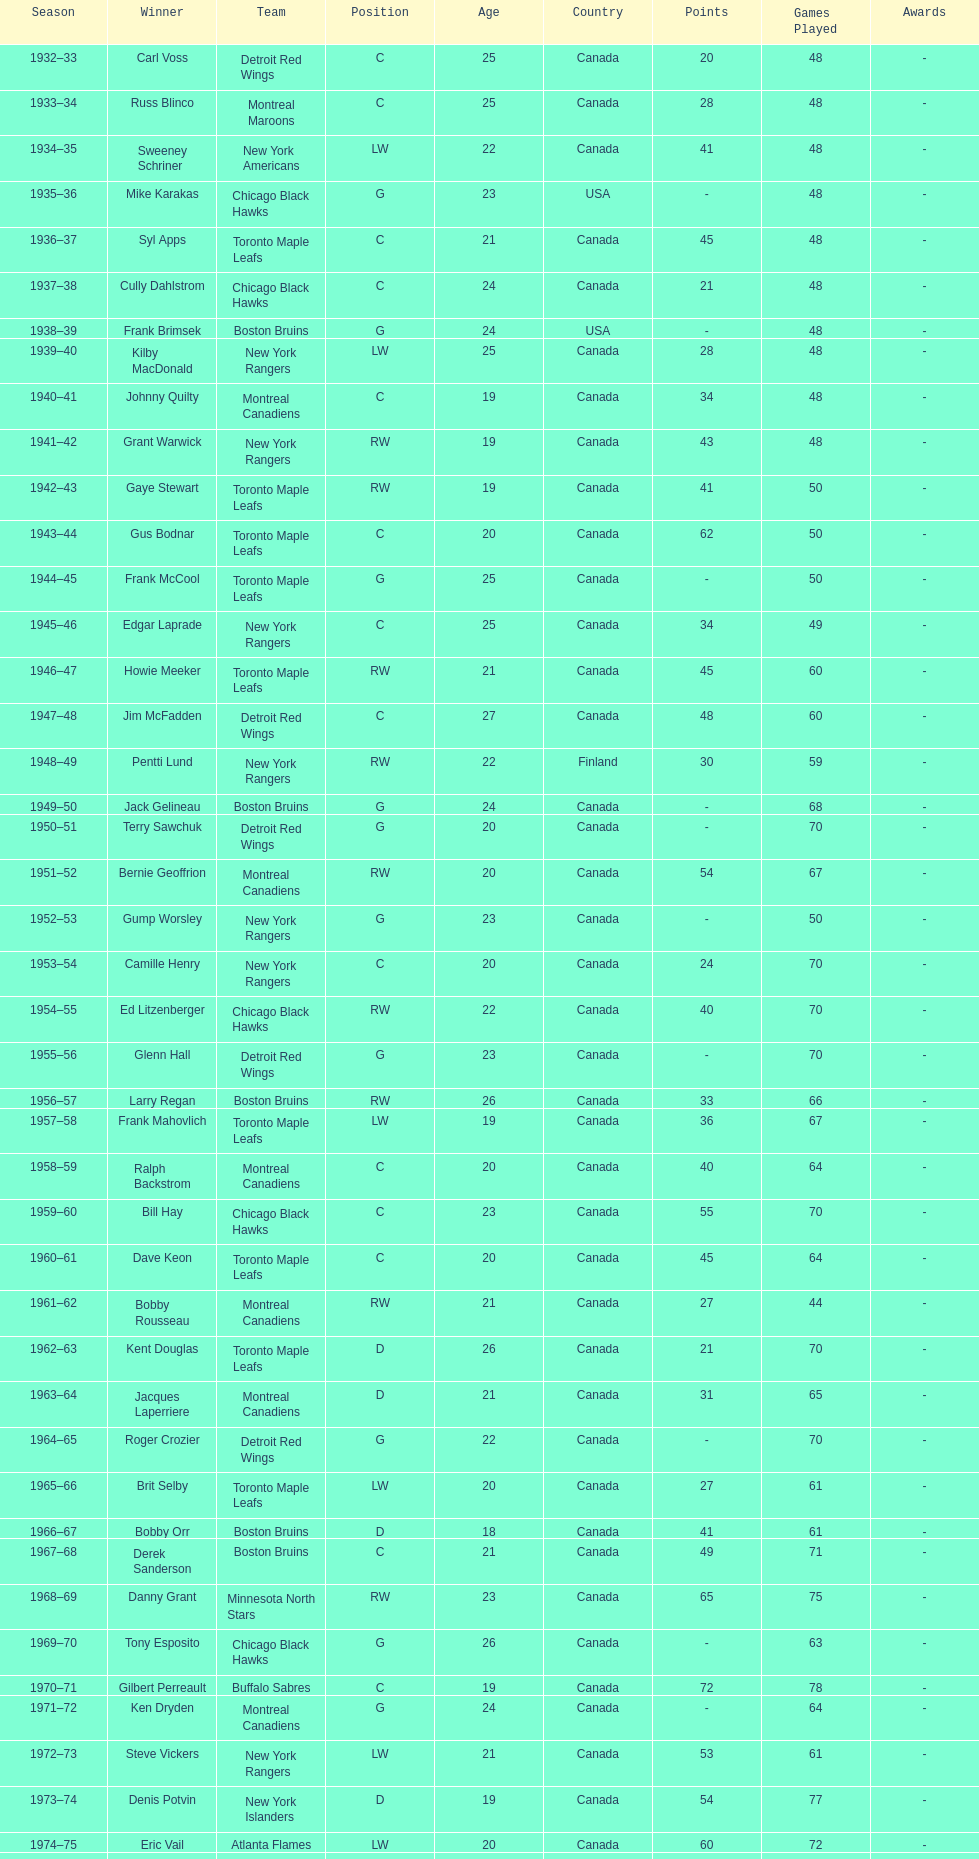Who was the first calder memorial trophy winner from the boston bruins? Frank Brimsek. 